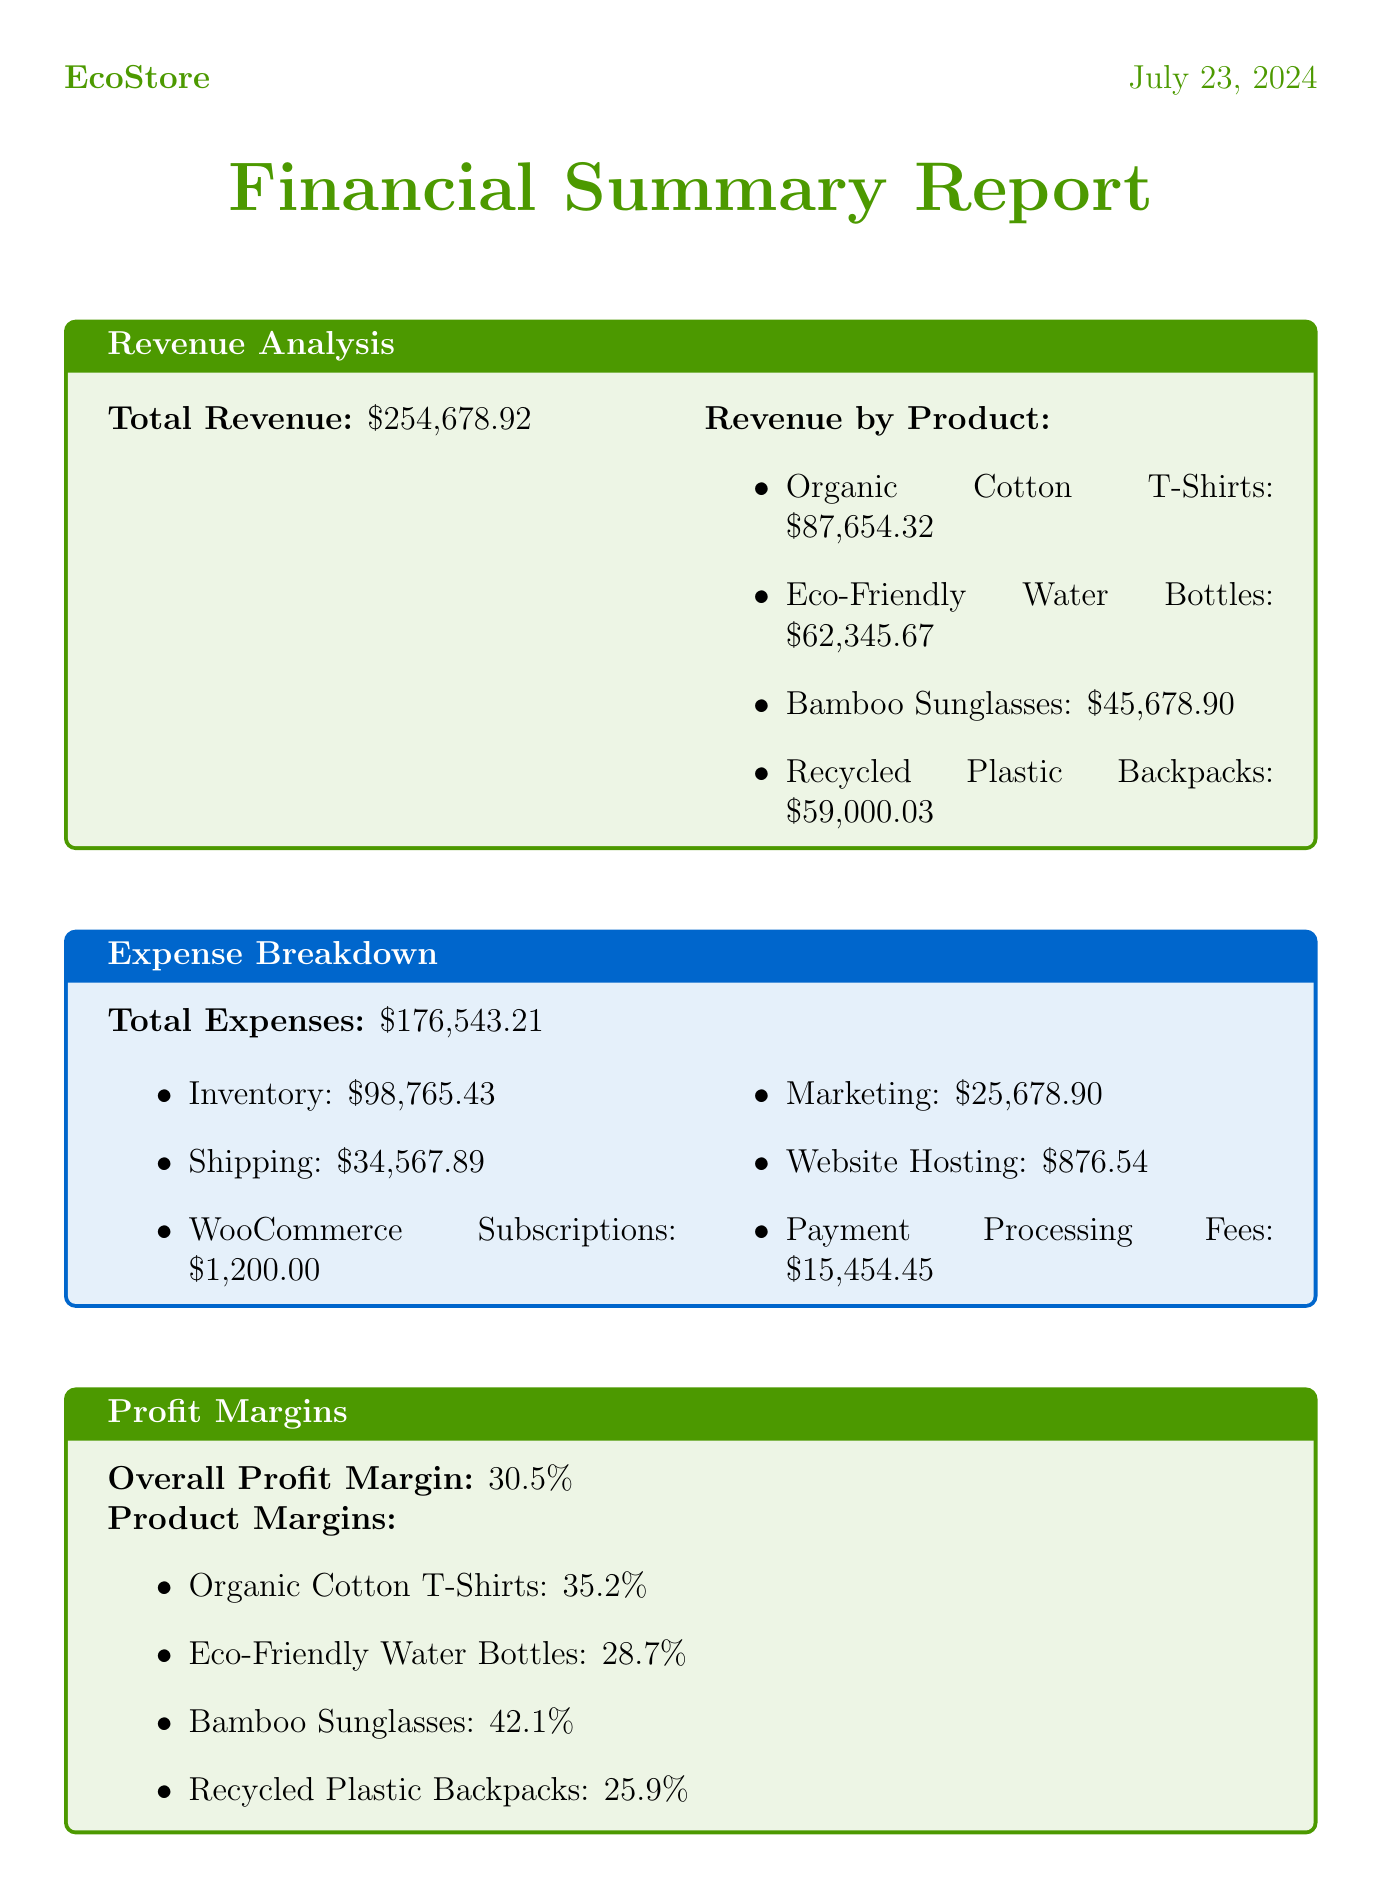What is the total revenue? The total revenue is listed in the revenue analysis section of the document and is $254,678.92.
Answer: $254,678.92 What were the total expenses? The total expenses amount is provided under the expense breakdown section and is $176,543.21.
Answer: $176,543.21 What is the overall profit margin? The overall profit margin can be found in the profit margins section and is 30.5%.
Answer: 30.5% Which product had the highest margin? The product with the highest margin is identified in the profit margins section and is Bamboo Sunglasses with a margin of 42.1%.
Answer: Bamboo Sunglasses What is the projected profit for May? The projected profit for May is included in the cash flow projections table and is $8,888.89.
Answer: $8,888.89 What was the average order value? The average order value can be found in the WooCommerce metrics and is $78.54.
Answer: $78.54 What characterizes the customer acquisition cost from Google Ads? The customer acquisition cost via Google Ads is specified in the customer acquisition cost section and amounts to $18.76.
Answer: $18.76 What is the inventory turnover rate? The inventory turnover rate is mentioned in the additional metrics section and is 6.7.
Answer: 6.7 Which product sold the most units? The product that sold the most units is detailed in the top-selling products section and is Organic Cotton T-Shirts with 1,234 units sold.
Answer: Organic Cotton T-Shirts 